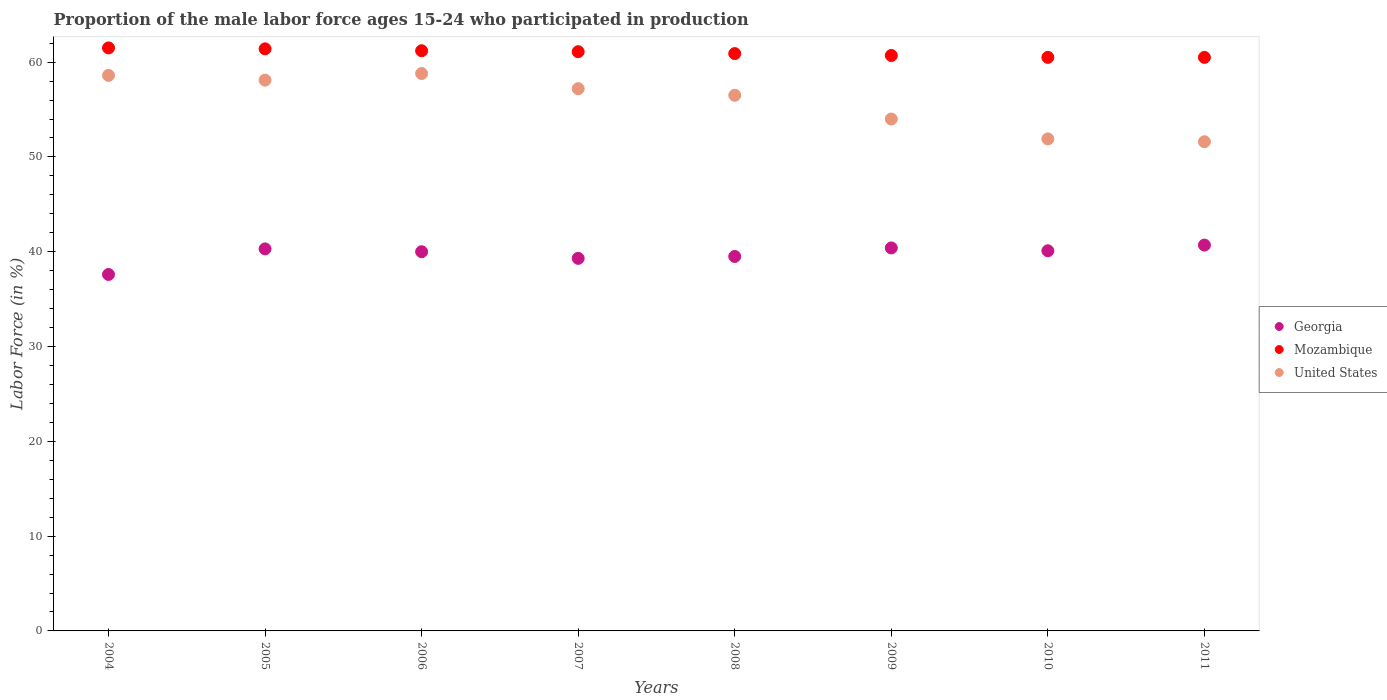Is the number of dotlines equal to the number of legend labels?
Ensure brevity in your answer.  Yes. What is the proportion of the male labor force who participated in production in Georgia in 2009?
Keep it short and to the point. 40.4. Across all years, what is the maximum proportion of the male labor force who participated in production in Mozambique?
Your response must be concise. 61.5. Across all years, what is the minimum proportion of the male labor force who participated in production in Georgia?
Provide a succinct answer. 37.6. What is the total proportion of the male labor force who participated in production in United States in the graph?
Provide a succinct answer. 446.7. What is the difference between the proportion of the male labor force who participated in production in Mozambique in 2004 and that in 2006?
Your response must be concise. 0.3. What is the difference between the proportion of the male labor force who participated in production in Mozambique in 2009 and the proportion of the male labor force who participated in production in United States in 2008?
Ensure brevity in your answer.  4.2. What is the average proportion of the male labor force who participated in production in United States per year?
Provide a short and direct response. 55.84. In the year 2008, what is the difference between the proportion of the male labor force who participated in production in United States and proportion of the male labor force who participated in production in Mozambique?
Your response must be concise. -4.4. In how many years, is the proportion of the male labor force who participated in production in Georgia greater than 12 %?
Your answer should be very brief. 8. What is the ratio of the proportion of the male labor force who participated in production in United States in 2006 to that in 2011?
Give a very brief answer. 1.14. Is the difference between the proportion of the male labor force who participated in production in United States in 2006 and 2010 greater than the difference between the proportion of the male labor force who participated in production in Mozambique in 2006 and 2010?
Give a very brief answer. Yes. What is the difference between the highest and the second highest proportion of the male labor force who participated in production in Georgia?
Offer a terse response. 0.3. What is the difference between the highest and the lowest proportion of the male labor force who participated in production in Mozambique?
Your answer should be very brief. 1. Is the sum of the proportion of the male labor force who participated in production in Georgia in 2005 and 2009 greater than the maximum proportion of the male labor force who participated in production in United States across all years?
Provide a succinct answer. Yes. Is it the case that in every year, the sum of the proportion of the male labor force who participated in production in United States and proportion of the male labor force who participated in production in Mozambique  is greater than the proportion of the male labor force who participated in production in Georgia?
Offer a very short reply. Yes. Is the proportion of the male labor force who participated in production in United States strictly greater than the proportion of the male labor force who participated in production in Georgia over the years?
Offer a terse response. Yes. How many dotlines are there?
Give a very brief answer. 3. Does the graph contain any zero values?
Your answer should be very brief. No. Where does the legend appear in the graph?
Your response must be concise. Center right. How many legend labels are there?
Ensure brevity in your answer.  3. How are the legend labels stacked?
Provide a succinct answer. Vertical. What is the title of the graph?
Ensure brevity in your answer.  Proportion of the male labor force ages 15-24 who participated in production. Does "Middle East & North Africa (all income levels)" appear as one of the legend labels in the graph?
Your response must be concise. No. What is the label or title of the X-axis?
Your response must be concise. Years. What is the label or title of the Y-axis?
Your response must be concise. Labor Force (in %). What is the Labor Force (in %) in Georgia in 2004?
Give a very brief answer. 37.6. What is the Labor Force (in %) in Mozambique in 2004?
Offer a very short reply. 61.5. What is the Labor Force (in %) in United States in 2004?
Offer a terse response. 58.6. What is the Labor Force (in %) in Georgia in 2005?
Give a very brief answer. 40.3. What is the Labor Force (in %) in Mozambique in 2005?
Your response must be concise. 61.4. What is the Labor Force (in %) in United States in 2005?
Keep it short and to the point. 58.1. What is the Labor Force (in %) of Georgia in 2006?
Make the answer very short. 40. What is the Labor Force (in %) in Mozambique in 2006?
Offer a terse response. 61.2. What is the Labor Force (in %) of United States in 2006?
Your answer should be compact. 58.8. What is the Labor Force (in %) in Georgia in 2007?
Offer a very short reply. 39.3. What is the Labor Force (in %) of Mozambique in 2007?
Give a very brief answer. 61.1. What is the Labor Force (in %) in United States in 2007?
Your response must be concise. 57.2. What is the Labor Force (in %) in Georgia in 2008?
Keep it short and to the point. 39.5. What is the Labor Force (in %) of Mozambique in 2008?
Ensure brevity in your answer.  60.9. What is the Labor Force (in %) in United States in 2008?
Offer a terse response. 56.5. What is the Labor Force (in %) in Georgia in 2009?
Offer a terse response. 40.4. What is the Labor Force (in %) in Mozambique in 2009?
Offer a terse response. 60.7. What is the Labor Force (in %) of United States in 2009?
Keep it short and to the point. 54. What is the Labor Force (in %) in Georgia in 2010?
Your answer should be very brief. 40.1. What is the Labor Force (in %) of Mozambique in 2010?
Your answer should be very brief. 60.5. What is the Labor Force (in %) of United States in 2010?
Offer a terse response. 51.9. What is the Labor Force (in %) in Georgia in 2011?
Provide a succinct answer. 40.7. What is the Labor Force (in %) of Mozambique in 2011?
Provide a succinct answer. 60.5. What is the Labor Force (in %) of United States in 2011?
Give a very brief answer. 51.6. Across all years, what is the maximum Labor Force (in %) in Georgia?
Your answer should be compact. 40.7. Across all years, what is the maximum Labor Force (in %) of Mozambique?
Offer a terse response. 61.5. Across all years, what is the maximum Labor Force (in %) in United States?
Offer a very short reply. 58.8. Across all years, what is the minimum Labor Force (in %) of Georgia?
Provide a succinct answer. 37.6. Across all years, what is the minimum Labor Force (in %) in Mozambique?
Ensure brevity in your answer.  60.5. Across all years, what is the minimum Labor Force (in %) in United States?
Offer a terse response. 51.6. What is the total Labor Force (in %) in Georgia in the graph?
Provide a short and direct response. 317.9. What is the total Labor Force (in %) in Mozambique in the graph?
Offer a very short reply. 487.8. What is the total Labor Force (in %) in United States in the graph?
Your answer should be very brief. 446.7. What is the difference between the Labor Force (in %) of Georgia in 2004 and that in 2005?
Make the answer very short. -2.7. What is the difference between the Labor Force (in %) in Mozambique in 2004 and that in 2005?
Provide a succinct answer. 0.1. What is the difference between the Labor Force (in %) of United States in 2004 and that in 2005?
Offer a terse response. 0.5. What is the difference between the Labor Force (in %) of Mozambique in 2004 and that in 2006?
Make the answer very short. 0.3. What is the difference between the Labor Force (in %) in Mozambique in 2004 and that in 2007?
Give a very brief answer. 0.4. What is the difference between the Labor Force (in %) in Mozambique in 2004 and that in 2008?
Keep it short and to the point. 0.6. What is the difference between the Labor Force (in %) of United States in 2004 and that in 2008?
Your response must be concise. 2.1. What is the difference between the Labor Force (in %) of Georgia in 2004 and that in 2009?
Your answer should be compact. -2.8. What is the difference between the Labor Force (in %) of Mozambique in 2004 and that in 2009?
Offer a terse response. 0.8. What is the difference between the Labor Force (in %) in Mozambique in 2005 and that in 2007?
Make the answer very short. 0.3. What is the difference between the Labor Force (in %) of Mozambique in 2005 and that in 2008?
Offer a terse response. 0.5. What is the difference between the Labor Force (in %) in United States in 2005 and that in 2008?
Your answer should be very brief. 1.6. What is the difference between the Labor Force (in %) in Mozambique in 2005 and that in 2009?
Give a very brief answer. 0.7. What is the difference between the Labor Force (in %) in United States in 2005 and that in 2009?
Your answer should be compact. 4.1. What is the difference between the Labor Force (in %) of Georgia in 2005 and that in 2010?
Give a very brief answer. 0.2. What is the difference between the Labor Force (in %) in Georgia in 2006 and that in 2007?
Make the answer very short. 0.7. What is the difference between the Labor Force (in %) in United States in 2006 and that in 2008?
Offer a very short reply. 2.3. What is the difference between the Labor Force (in %) of Georgia in 2006 and that in 2010?
Ensure brevity in your answer.  -0.1. What is the difference between the Labor Force (in %) in United States in 2006 and that in 2010?
Provide a succinct answer. 6.9. What is the difference between the Labor Force (in %) of Mozambique in 2006 and that in 2011?
Your answer should be very brief. 0.7. What is the difference between the Labor Force (in %) of Georgia in 2007 and that in 2008?
Make the answer very short. -0.2. What is the difference between the Labor Force (in %) of Mozambique in 2007 and that in 2008?
Offer a very short reply. 0.2. What is the difference between the Labor Force (in %) of United States in 2007 and that in 2008?
Keep it short and to the point. 0.7. What is the difference between the Labor Force (in %) in Georgia in 2007 and that in 2009?
Ensure brevity in your answer.  -1.1. What is the difference between the Labor Force (in %) in Mozambique in 2007 and that in 2009?
Provide a succinct answer. 0.4. What is the difference between the Labor Force (in %) of Mozambique in 2007 and that in 2010?
Your answer should be very brief. 0.6. What is the difference between the Labor Force (in %) of Georgia in 2007 and that in 2011?
Provide a succinct answer. -1.4. What is the difference between the Labor Force (in %) of Georgia in 2008 and that in 2009?
Ensure brevity in your answer.  -0.9. What is the difference between the Labor Force (in %) of United States in 2008 and that in 2009?
Offer a terse response. 2.5. What is the difference between the Labor Force (in %) in Mozambique in 2008 and that in 2010?
Keep it short and to the point. 0.4. What is the difference between the Labor Force (in %) of United States in 2008 and that in 2011?
Your answer should be very brief. 4.9. What is the difference between the Labor Force (in %) of Mozambique in 2009 and that in 2010?
Keep it short and to the point. 0.2. What is the difference between the Labor Force (in %) of Georgia in 2009 and that in 2011?
Keep it short and to the point. -0.3. What is the difference between the Labor Force (in %) of Mozambique in 2009 and that in 2011?
Offer a terse response. 0.2. What is the difference between the Labor Force (in %) of Georgia in 2010 and that in 2011?
Keep it short and to the point. -0.6. What is the difference between the Labor Force (in %) of Georgia in 2004 and the Labor Force (in %) of Mozambique in 2005?
Ensure brevity in your answer.  -23.8. What is the difference between the Labor Force (in %) in Georgia in 2004 and the Labor Force (in %) in United States in 2005?
Make the answer very short. -20.5. What is the difference between the Labor Force (in %) of Georgia in 2004 and the Labor Force (in %) of Mozambique in 2006?
Your answer should be very brief. -23.6. What is the difference between the Labor Force (in %) in Georgia in 2004 and the Labor Force (in %) in United States in 2006?
Give a very brief answer. -21.2. What is the difference between the Labor Force (in %) of Georgia in 2004 and the Labor Force (in %) of Mozambique in 2007?
Your answer should be compact. -23.5. What is the difference between the Labor Force (in %) in Georgia in 2004 and the Labor Force (in %) in United States in 2007?
Provide a succinct answer. -19.6. What is the difference between the Labor Force (in %) in Georgia in 2004 and the Labor Force (in %) in Mozambique in 2008?
Provide a succinct answer. -23.3. What is the difference between the Labor Force (in %) of Georgia in 2004 and the Labor Force (in %) of United States in 2008?
Make the answer very short. -18.9. What is the difference between the Labor Force (in %) of Mozambique in 2004 and the Labor Force (in %) of United States in 2008?
Make the answer very short. 5. What is the difference between the Labor Force (in %) of Georgia in 2004 and the Labor Force (in %) of Mozambique in 2009?
Your answer should be compact. -23.1. What is the difference between the Labor Force (in %) in Georgia in 2004 and the Labor Force (in %) in United States in 2009?
Make the answer very short. -16.4. What is the difference between the Labor Force (in %) in Georgia in 2004 and the Labor Force (in %) in Mozambique in 2010?
Your answer should be very brief. -22.9. What is the difference between the Labor Force (in %) of Georgia in 2004 and the Labor Force (in %) of United States in 2010?
Make the answer very short. -14.3. What is the difference between the Labor Force (in %) of Mozambique in 2004 and the Labor Force (in %) of United States in 2010?
Offer a very short reply. 9.6. What is the difference between the Labor Force (in %) in Georgia in 2004 and the Labor Force (in %) in Mozambique in 2011?
Offer a very short reply. -22.9. What is the difference between the Labor Force (in %) of Georgia in 2004 and the Labor Force (in %) of United States in 2011?
Your response must be concise. -14. What is the difference between the Labor Force (in %) in Mozambique in 2004 and the Labor Force (in %) in United States in 2011?
Provide a succinct answer. 9.9. What is the difference between the Labor Force (in %) of Georgia in 2005 and the Labor Force (in %) of Mozambique in 2006?
Offer a terse response. -20.9. What is the difference between the Labor Force (in %) in Georgia in 2005 and the Labor Force (in %) in United States in 2006?
Your response must be concise. -18.5. What is the difference between the Labor Force (in %) in Mozambique in 2005 and the Labor Force (in %) in United States in 2006?
Make the answer very short. 2.6. What is the difference between the Labor Force (in %) of Georgia in 2005 and the Labor Force (in %) of Mozambique in 2007?
Your answer should be very brief. -20.8. What is the difference between the Labor Force (in %) of Georgia in 2005 and the Labor Force (in %) of United States in 2007?
Offer a very short reply. -16.9. What is the difference between the Labor Force (in %) of Georgia in 2005 and the Labor Force (in %) of Mozambique in 2008?
Provide a short and direct response. -20.6. What is the difference between the Labor Force (in %) in Georgia in 2005 and the Labor Force (in %) in United States in 2008?
Offer a very short reply. -16.2. What is the difference between the Labor Force (in %) in Mozambique in 2005 and the Labor Force (in %) in United States in 2008?
Your answer should be very brief. 4.9. What is the difference between the Labor Force (in %) in Georgia in 2005 and the Labor Force (in %) in Mozambique in 2009?
Offer a very short reply. -20.4. What is the difference between the Labor Force (in %) in Georgia in 2005 and the Labor Force (in %) in United States in 2009?
Provide a succinct answer. -13.7. What is the difference between the Labor Force (in %) of Mozambique in 2005 and the Labor Force (in %) of United States in 2009?
Your response must be concise. 7.4. What is the difference between the Labor Force (in %) in Georgia in 2005 and the Labor Force (in %) in Mozambique in 2010?
Give a very brief answer. -20.2. What is the difference between the Labor Force (in %) in Georgia in 2005 and the Labor Force (in %) in Mozambique in 2011?
Provide a short and direct response. -20.2. What is the difference between the Labor Force (in %) in Georgia in 2005 and the Labor Force (in %) in United States in 2011?
Provide a short and direct response. -11.3. What is the difference between the Labor Force (in %) of Mozambique in 2005 and the Labor Force (in %) of United States in 2011?
Provide a short and direct response. 9.8. What is the difference between the Labor Force (in %) in Georgia in 2006 and the Labor Force (in %) in Mozambique in 2007?
Your response must be concise. -21.1. What is the difference between the Labor Force (in %) in Georgia in 2006 and the Labor Force (in %) in United States in 2007?
Give a very brief answer. -17.2. What is the difference between the Labor Force (in %) of Georgia in 2006 and the Labor Force (in %) of Mozambique in 2008?
Your answer should be compact. -20.9. What is the difference between the Labor Force (in %) of Georgia in 2006 and the Labor Force (in %) of United States in 2008?
Give a very brief answer. -16.5. What is the difference between the Labor Force (in %) in Mozambique in 2006 and the Labor Force (in %) in United States in 2008?
Your answer should be compact. 4.7. What is the difference between the Labor Force (in %) in Georgia in 2006 and the Labor Force (in %) in Mozambique in 2009?
Your answer should be very brief. -20.7. What is the difference between the Labor Force (in %) in Georgia in 2006 and the Labor Force (in %) in United States in 2009?
Offer a very short reply. -14. What is the difference between the Labor Force (in %) of Mozambique in 2006 and the Labor Force (in %) of United States in 2009?
Give a very brief answer. 7.2. What is the difference between the Labor Force (in %) of Georgia in 2006 and the Labor Force (in %) of Mozambique in 2010?
Offer a terse response. -20.5. What is the difference between the Labor Force (in %) in Georgia in 2006 and the Labor Force (in %) in United States in 2010?
Ensure brevity in your answer.  -11.9. What is the difference between the Labor Force (in %) of Mozambique in 2006 and the Labor Force (in %) of United States in 2010?
Offer a very short reply. 9.3. What is the difference between the Labor Force (in %) in Georgia in 2006 and the Labor Force (in %) in Mozambique in 2011?
Give a very brief answer. -20.5. What is the difference between the Labor Force (in %) in Georgia in 2007 and the Labor Force (in %) in Mozambique in 2008?
Offer a terse response. -21.6. What is the difference between the Labor Force (in %) of Georgia in 2007 and the Labor Force (in %) of United States in 2008?
Give a very brief answer. -17.2. What is the difference between the Labor Force (in %) of Mozambique in 2007 and the Labor Force (in %) of United States in 2008?
Offer a terse response. 4.6. What is the difference between the Labor Force (in %) in Georgia in 2007 and the Labor Force (in %) in Mozambique in 2009?
Your response must be concise. -21.4. What is the difference between the Labor Force (in %) of Georgia in 2007 and the Labor Force (in %) of United States in 2009?
Make the answer very short. -14.7. What is the difference between the Labor Force (in %) of Georgia in 2007 and the Labor Force (in %) of Mozambique in 2010?
Ensure brevity in your answer.  -21.2. What is the difference between the Labor Force (in %) in Georgia in 2007 and the Labor Force (in %) in Mozambique in 2011?
Provide a short and direct response. -21.2. What is the difference between the Labor Force (in %) in Georgia in 2007 and the Labor Force (in %) in United States in 2011?
Your answer should be compact. -12.3. What is the difference between the Labor Force (in %) in Mozambique in 2007 and the Labor Force (in %) in United States in 2011?
Offer a very short reply. 9.5. What is the difference between the Labor Force (in %) in Georgia in 2008 and the Labor Force (in %) in Mozambique in 2009?
Keep it short and to the point. -21.2. What is the difference between the Labor Force (in %) in Mozambique in 2008 and the Labor Force (in %) in United States in 2009?
Provide a short and direct response. 6.9. What is the difference between the Labor Force (in %) in Mozambique in 2008 and the Labor Force (in %) in United States in 2010?
Give a very brief answer. 9. What is the difference between the Labor Force (in %) in Georgia in 2008 and the Labor Force (in %) in Mozambique in 2011?
Offer a terse response. -21. What is the difference between the Labor Force (in %) of Georgia in 2008 and the Labor Force (in %) of United States in 2011?
Offer a terse response. -12.1. What is the difference between the Labor Force (in %) of Georgia in 2009 and the Labor Force (in %) of Mozambique in 2010?
Provide a short and direct response. -20.1. What is the difference between the Labor Force (in %) of Georgia in 2009 and the Labor Force (in %) of United States in 2010?
Your answer should be very brief. -11.5. What is the difference between the Labor Force (in %) of Georgia in 2009 and the Labor Force (in %) of Mozambique in 2011?
Give a very brief answer. -20.1. What is the difference between the Labor Force (in %) of Georgia in 2010 and the Labor Force (in %) of Mozambique in 2011?
Your answer should be compact. -20.4. What is the average Labor Force (in %) of Georgia per year?
Make the answer very short. 39.74. What is the average Labor Force (in %) in Mozambique per year?
Keep it short and to the point. 60.98. What is the average Labor Force (in %) in United States per year?
Your response must be concise. 55.84. In the year 2004, what is the difference between the Labor Force (in %) in Georgia and Labor Force (in %) in Mozambique?
Your response must be concise. -23.9. In the year 2004, what is the difference between the Labor Force (in %) of Georgia and Labor Force (in %) of United States?
Offer a terse response. -21. In the year 2005, what is the difference between the Labor Force (in %) of Georgia and Labor Force (in %) of Mozambique?
Your answer should be compact. -21.1. In the year 2005, what is the difference between the Labor Force (in %) of Georgia and Labor Force (in %) of United States?
Keep it short and to the point. -17.8. In the year 2006, what is the difference between the Labor Force (in %) of Georgia and Labor Force (in %) of Mozambique?
Make the answer very short. -21.2. In the year 2006, what is the difference between the Labor Force (in %) of Georgia and Labor Force (in %) of United States?
Your answer should be very brief. -18.8. In the year 2007, what is the difference between the Labor Force (in %) in Georgia and Labor Force (in %) in Mozambique?
Offer a terse response. -21.8. In the year 2007, what is the difference between the Labor Force (in %) of Georgia and Labor Force (in %) of United States?
Offer a very short reply. -17.9. In the year 2008, what is the difference between the Labor Force (in %) of Georgia and Labor Force (in %) of Mozambique?
Make the answer very short. -21.4. In the year 2008, what is the difference between the Labor Force (in %) of Mozambique and Labor Force (in %) of United States?
Give a very brief answer. 4.4. In the year 2009, what is the difference between the Labor Force (in %) of Georgia and Labor Force (in %) of Mozambique?
Keep it short and to the point. -20.3. In the year 2009, what is the difference between the Labor Force (in %) of Georgia and Labor Force (in %) of United States?
Your response must be concise. -13.6. In the year 2010, what is the difference between the Labor Force (in %) of Georgia and Labor Force (in %) of Mozambique?
Make the answer very short. -20.4. In the year 2011, what is the difference between the Labor Force (in %) in Georgia and Labor Force (in %) in Mozambique?
Your answer should be compact. -19.8. In the year 2011, what is the difference between the Labor Force (in %) in Georgia and Labor Force (in %) in United States?
Offer a very short reply. -10.9. What is the ratio of the Labor Force (in %) of Georgia in 2004 to that in 2005?
Offer a terse response. 0.93. What is the ratio of the Labor Force (in %) of Mozambique in 2004 to that in 2005?
Give a very brief answer. 1. What is the ratio of the Labor Force (in %) of United States in 2004 to that in 2005?
Your response must be concise. 1.01. What is the ratio of the Labor Force (in %) in Georgia in 2004 to that in 2006?
Your answer should be very brief. 0.94. What is the ratio of the Labor Force (in %) in United States in 2004 to that in 2006?
Give a very brief answer. 1. What is the ratio of the Labor Force (in %) in Georgia in 2004 to that in 2007?
Provide a short and direct response. 0.96. What is the ratio of the Labor Force (in %) of United States in 2004 to that in 2007?
Make the answer very short. 1.02. What is the ratio of the Labor Force (in %) of Georgia in 2004 to that in 2008?
Give a very brief answer. 0.95. What is the ratio of the Labor Force (in %) of Mozambique in 2004 to that in 2008?
Give a very brief answer. 1.01. What is the ratio of the Labor Force (in %) of United States in 2004 to that in 2008?
Provide a succinct answer. 1.04. What is the ratio of the Labor Force (in %) of Georgia in 2004 to that in 2009?
Give a very brief answer. 0.93. What is the ratio of the Labor Force (in %) in Mozambique in 2004 to that in 2009?
Your response must be concise. 1.01. What is the ratio of the Labor Force (in %) of United States in 2004 to that in 2009?
Offer a terse response. 1.09. What is the ratio of the Labor Force (in %) in Georgia in 2004 to that in 2010?
Your answer should be very brief. 0.94. What is the ratio of the Labor Force (in %) of Mozambique in 2004 to that in 2010?
Make the answer very short. 1.02. What is the ratio of the Labor Force (in %) of United States in 2004 to that in 2010?
Keep it short and to the point. 1.13. What is the ratio of the Labor Force (in %) of Georgia in 2004 to that in 2011?
Offer a terse response. 0.92. What is the ratio of the Labor Force (in %) in Mozambique in 2004 to that in 2011?
Give a very brief answer. 1.02. What is the ratio of the Labor Force (in %) of United States in 2004 to that in 2011?
Make the answer very short. 1.14. What is the ratio of the Labor Force (in %) in Georgia in 2005 to that in 2006?
Your response must be concise. 1.01. What is the ratio of the Labor Force (in %) in United States in 2005 to that in 2006?
Offer a terse response. 0.99. What is the ratio of the Labor Force (in %) in Georgia in 2005 to that in 2007?
Offer a terse response. 1.03. What is the ratio of the Labor Force (in %) in Mozambique in 2005 to that in 2007?
Make the answer very short. 1. What is the ratio of the Labor Force (in %) of United States in 2005 to that in 2007?
Give a very brief answer. 1.02. What is the ratio of the Labor Force (in %) in Georgia in 2005 to that in 2008?
Provide a succinct answer. 1.02. What is the ratio of the Labor Force (in %) of Mozambique in 2005 to that in 2008?
Your answer should be very brief. 1.01. What is the ratio of the Labor Force (in %) in United States in 2005 to that in 2008?
Make the answer very short. 1.03. What is the ratio of the Labor Force (in %) of Mozambique in 2005 to that in 2009?
Keep it short and to the point. 1.01. What is the ratio of the Labor Force (in %) in United States in 2005 to that in 2009?
Ensure brevity in your answer.  1.08. What is the ratio of the Labor Force (in %) in Georgia in 2005 to that in 2010?
Provide a succinct answer. 1. What is the ratio of the Labor Force (in %) in Mozambique in 2005 to that in 2010?
Offer a very short reply. 1.01. What is the ratio of the Labor Force (in %) of United States in 2005 to that in 2010?
Your response must be concise. 1.12. What is the ratio of the Labor Force (in %) of Georgia in 2005 to that in 2011?
Keep it short and to the point. 0.99. What is the ratio of the Labor Force (in %) in Mozambique in 2005 to that in 2011?
Provide a succinct answer. 1.01. What is the ratio of the Labor Force (in %) of United States in 2005 to that in 2011?
Provide a short and direct response. 1.13. What is the ratio of the Labor Force (in %) in Georgia in 2006 to that in 2007?
Make the answer very short. 1.02. What is the ratio of the Labor Force (in %) of United States in 2006 to that in 2007?
Provide a short and direct response. 1.03. What is the ratio of the Labor Force (in %) in Georgia in 2006 to that in 2008?
Give a very brief answer. 1.01. What is the ratio of the Labor Force (in %) in United States in 2006 to that in 2008?
Make the answer very short. 1.04. What is the ratio of the Labor Force (in %) in Georgia in 2006 to that in 2009?
Keep it short and to the point. 0.99. What is the ratio of the Labor Force (in %) in Mozambique in 2006 to that in 2009?
Give a very brief answer. 1.01. What is the ratio of the Labor Force (in %) in United States in 2006 to that in 2009?
Your response must be concise. 1.09. What is the ratio of the Labor Force (in %) in Georgia in 2006 to that in 2010?
Offer a terse response. 1. What is the ratio of the Labor Force (in %) of Mozambique in 2006 to that in 2010?
Your answer should be compact. 1.01. What is the ratio of the Labor Force (in %) of United States in 2006 to that in 2010?
Provide a short and direct response. 1.13. What is the ratio of the Labor Force (in %) in Georgia in 2006 to that in 2011?
Provide a short and direct response. 0.98. What is the ratio of the Labor Force (in %) of Mozambique in 2006 to that in 2011?
Provide a succinct answer. 1.01. What is the ratio of the Labor Force (in %) in United States in 2006 to that in 2011?
Offer a terse response. 1.14. What is the ratio of the Labor Force (in %) in Georgia in 2007 to that in 2008?
Ensure brevity in your answer.  0.99. What is the ratio of the Labor Force (in %) in United States in 2007 to that in 2008?
Ensure brevity in your answer.  1.01. What is the ratio of the Labor Force (in %) in Georgia in 2007 to that in 2009?
Give a very brief answer. 0.97. What is the ratio of the Labor Force (in %) of Mozambique in 2007 to that in 2009?
Provide a short and direct response. 1.01. What is the ratio of the Labor Force (in %) in United States in 2007 to that in 2009?
Keep it short and to the point. 1.06. What is the ratio of the Labor Force (in %) of Mozambique in 2007 to that in 2010?
Your response must be concise. 1.01. What is the ratio of the Labor Force (in %) in United States in 2007 to that in 2010?
Ensure brevity in your answer.  1.1. What is the ratio of the Labor Force (in %) of Georgia in 2007 to that in 2011?
Provide a succinct answer. 0.97. What is the ratio of the Labor Force (in %) in Mozambique in 2007 to that in 2011?
Your answer should be very brief. 1.01. What is the ratio of the Labor Force (in %) in United States in 2007 to that in 2011?
Offer a very short reply. 1.11. What is the ratio of the Labor Force (in %) of Georgia in 2008 to that in 2009?
Keep it short and to the point. 0.98. What is the ratio of the Labor Force (in %) in Mozambique in 2008 to that in 2009?
Provide a short and direct response. 1. What is the ratio of the Labor Force (in %) of United States in 2008 to that in 2009?
Make the answer very short. 1.05. What is the ratio of the Labor Force (in %) in Mozambique in 2008 to that in 2010?
Give a very brief answer. 1.01. What is the ratio of the Labor Force (in %) of United States in 2008 to that in 2010?
Ensure brevity in your answer.  1.09. What is the ratio of the Labor Force (in %) in Georgia in 2008 to that in 2011?
Ensure brevity in your answer.  0.97. What is the ratio of the Labor Force (in %) of Mozambique in 2008 to that in 2011?
Offer a terse response. 1.01. What is the ratio of the Labor Force (in %) in United States in 2008 to that in 2011?
Give a very brief answer. 1.09. What is the ratio of the Labor Force (in %) of Georgia in 2009 to that in 2010?
Offer a very short reply. 1.01. What is the ratio of the Labor Force (in %) in United States in 2009 to that in 2010?
Your answer should be compact. 1.04. What is the ratio of the Labor Force (in %) in Mozambique in 2009 to that in 2011?
Make the answer very short. 1. What is the ratio of the Labor Force (in %) in United States in 2009 to that in 2011?
Give a very brief answer. 1.05. What is the ratio of the Labor Force (in %) in Mozambique in 2010 to that in 2011?
Keep it short and to the point. 1. What is the ratio of the Labor Force (in %) in United States in 2010 to that in 2011?
Ensure brevity in your answer.  1.01. What is the difference between the highest and the second highest Labor Force (in %) in Georgia?
Offer a terse response. 0.3. What is the difference between the highest and the second highest Labor Force (in %) in United States?
Provide a short and direct response. 0.2. What is the difference between the highest and the lowest Labor Force (in %) in Georgia?
Offer a terse response. 3.1. What is the difference between the highest and the lowest Labor Force (in %) of Mozambique?
Ensure brevity in your answer.  1. What is the difference between the highest and the lowest Labor Force (in %) of United States?
Your answer should be very brief. 7.2. 